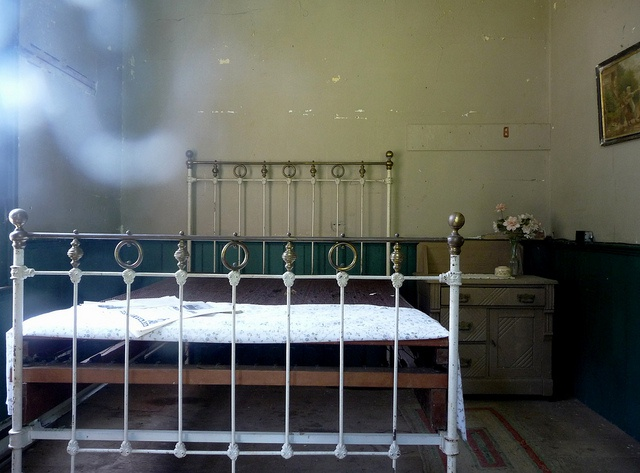Describe the objects in this image and their specific colors. I can see bed in lightblue, black, gray, white, and darkgray tones and vase in lightblue, black, and gray tones in this image. 